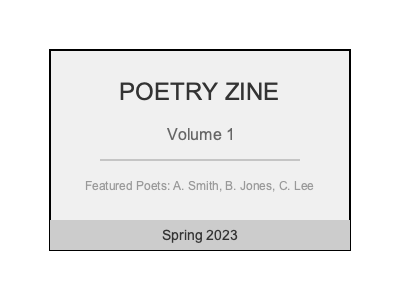Analyze the given poetry Zine cover design and explain how you would improve its visual hierarchy and composition to create a more effective and engaging cover. Consider the placement of elements, use of typography, and overall balance. To improve the visual hierarchy and composition of this poetry Zine cover, we should consider the following steps:

1. Emphasize the main title:
   - Increase the size of "POETRY ZINE" to make it the dominant element
   - Use a bolder or more distinctive font to create contrast
   - Consider adding color or a background shape to make it stand out

2. Restructure the layout:
   - Move "Volume 1" closer to the main title to create a clear relationship
   - Increase white space around the title to give it more prominence

3. Improve typography:
   - Use a more varied and hierarchical typographic system
   - Experiment with different font weights and styles for various elements

4. Enhance visual interest:
   - Introduce a relevant graphic element or illustration
   - Consider using a background pattern or texture

5. Adjust element placement:
   - Move "Spring 2023" to the top right corner for better balance
   - Align featured poets' names to the left or right edge for a cleaner look

6. Use color strategically:
   - Introduce a color scheme that reflects the Zine's content
   - Use color to create depth and guide the viewer's eye

7. Improve contrast:
   - Ensure sufficient contrast between text and background
   - Use varying shades or colors to differentiate information levels

8. Consider negative space:
   - Increase margins around the edge of the cover
   - Allow for more breathing room between elements

9. Add visual hierarchy to text:
   - Vary the size and weight of text elements based on their importance
   - Group related information together

10. Incorporate a focal point:
    - Add a striking visual element or use typography creatively to create a center of attention

By implementing these improvements, the cover will have a clearer visual hierarchy, improved composition, and be more visually appealing and effective in communicating its content.
Answer: Emphasize title, restructure layout, improve typography, add visual interest, adjust element placement, use strategic color, enhance contrast, utilize negative space, create text hierarchy, and incorporate a focal point. 